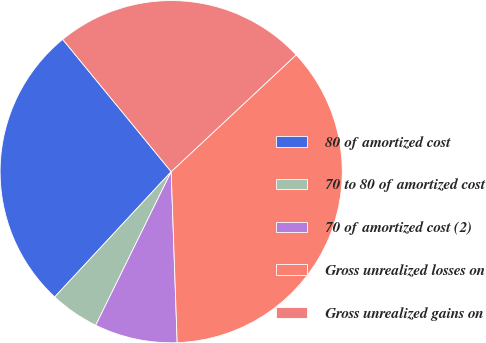Convert chart to OTSL. <chart><loc_0><loc_0><loc_500><loc_500><pie_chart><fcel>80 of amortized cost<fcel>70 to 80 of amortized cost<fcel>70 of amortized cost (2)<fcel>Gross unrealized losses on<fcel>Gross unrealized gains on<nl><fcel>27.15%<fcel>4.65%<fcel>7.83%<fcel>36.41%<fcel>23.97%<nl></chart> 